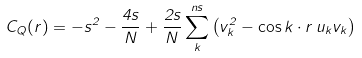<formula> <loc_0><loc_0><loc_500><loc_500>C _ { Q } ( r ) = - s ^ { 2 } - \frac { 4 s } { N } + \frac { 2 s } { N } \sum _ { k } ^ { n s } \left ( v _ { k } ^ { 2 } - \cos { k \cdot r } \, u _ { k } v _ { k } \right )</formula> 